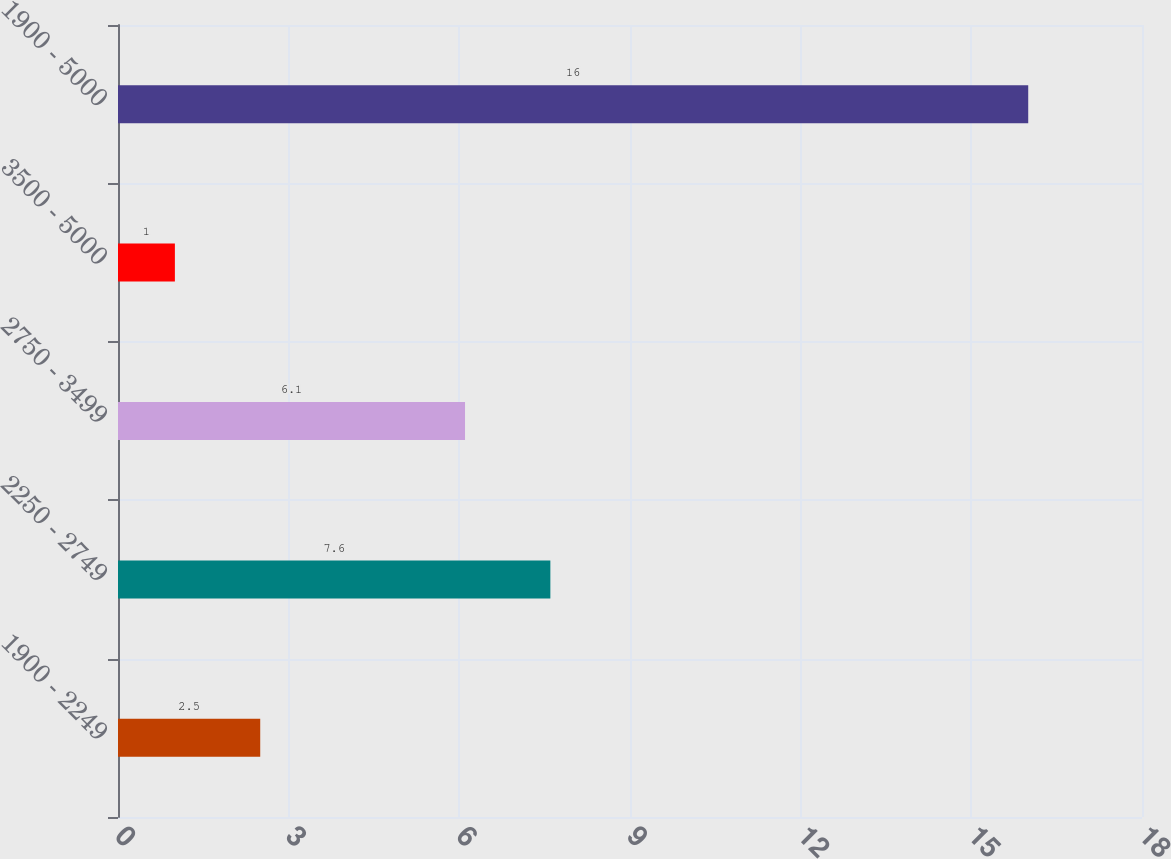Convert chart to OTSL. <chart><loc_0><loc_0><loc_500><loc_500><bar_chart><fcel>1900 - 2249<fcel>2250 - 2749<fcel>2750 - 3499<fcel>3500 - 5000<fcel>1900 - 5000<nl><fcel>2.5<fcel>7.6<fcel>6.1<fcel>1<fcel>16<nl></chart> 